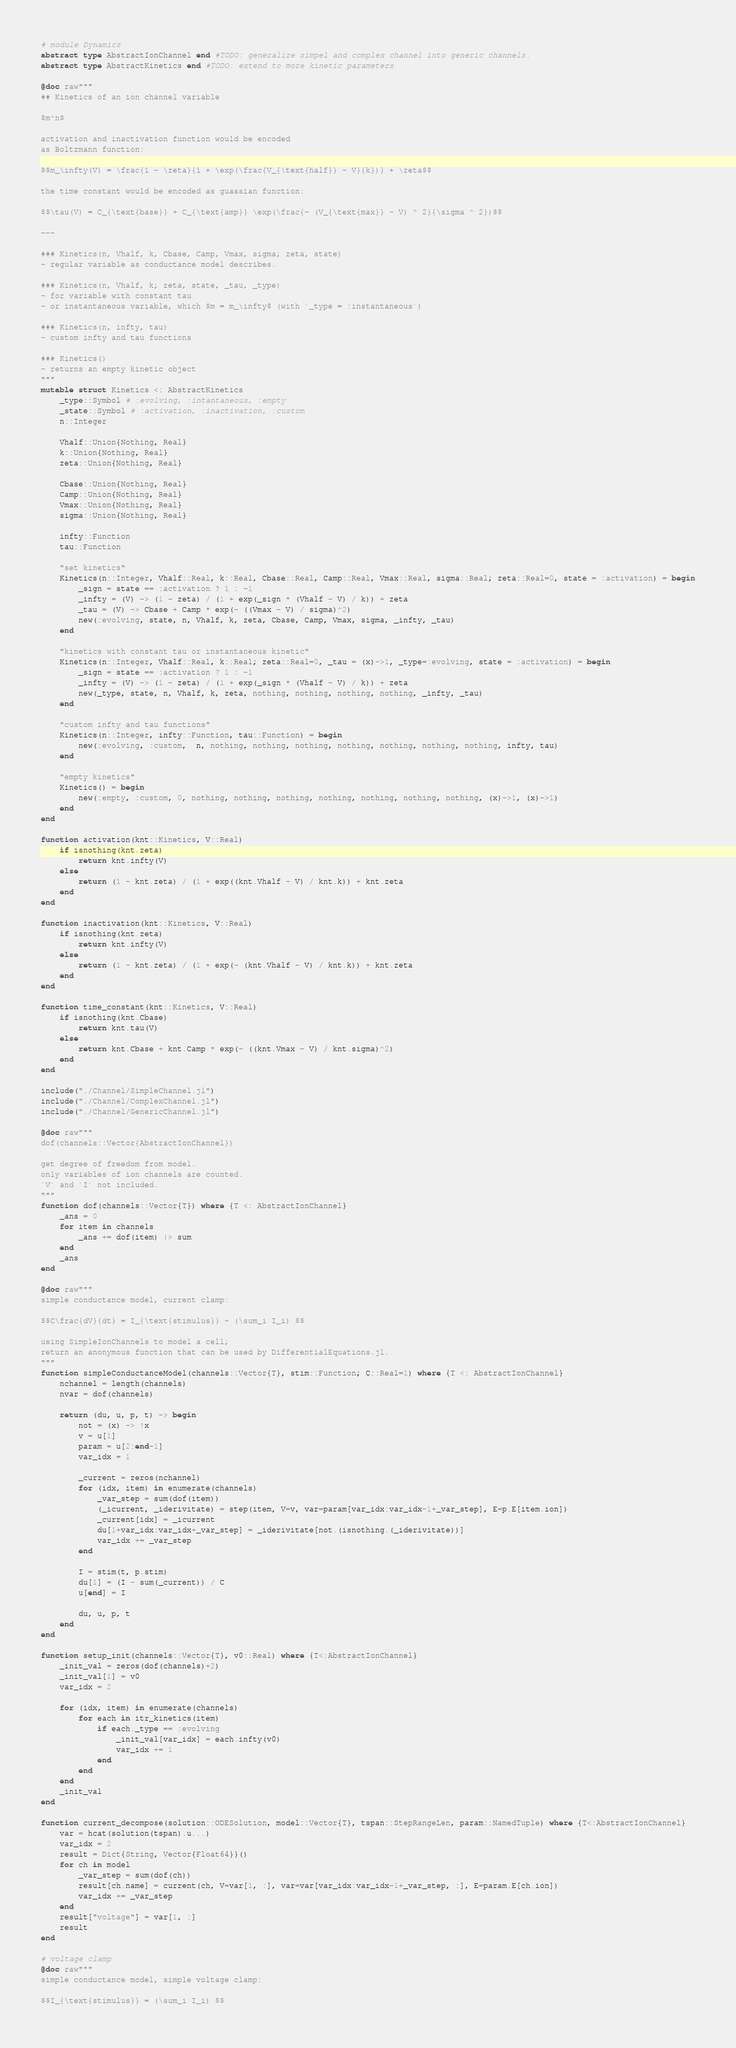Convert code to text. <code><loc_0><loc_0><loc_500><loc_500><_Julia_># module Dynamics
abstract type AbstractIonChannel end #TODO: generalize simpel and complex channel into generic channels.
abstract type AbstractKinetics end #TODO: extend to more kinetic parameters

@doc raw"""
## Kinetics of an ion channel variable

$m^n$

activation and inactivation function would be encoded
as Boltzmann function:

$$m_\infty(V) = \frac{1 - \zeta}{1 + \exp(\frac{V_{\text{half}} - V}{k})} + \zeta$$

the time constant would be encoded as guassian function:

$$\tau(V) = C_{\text{base}} + C_{\text{amp}} \exp(\frac{- (V_{\text{max}} - V) ^ 2}{\sigma ^ 2})$$

---

### Kinetics(n, Vhalf, k, Cbase, Camp, Vmax, sigma; zeta, state)
- regular variable as conductance model describes.

### Kinetics(n, Vhalf, k; zeta, state, _tau, _type)
- for variable with constant tau
- or instantaneous variable, which $m = m_\infty$ (with `_type = :instantaneous`)

### Kinetics(n, infty, tau)
- custom infty and tau functions

### Kinetics()
- returns an empty kinetic object
"""
mutable struct Kinetics <: AbstractKinetics
    _type::Symbol # :evolving, :intantaneous, :empty
    _state::Symbol # :activation, :inactivation, :custom
    n::Integer
    
    Vhalf::Union{Nothing, Real}
    k::Union{Nothing, Real}
    zeta::Union{Nothing, Real}

    Cbase::Union{Nothing, Real}
    Camp::Union{Nothing, Real}
    Vmax::Union{Nothing, Real}
    sigma::Union{Nothing, Real}

    infty::Function
    tau::Function

    "set kinetics"
    Kinetics(n::Integer, Vhalf::Real, k::Real, Cbase::Real, Camp::Real, Vmax::Real, sigma::Real; zeta::Real=0, state = :activation) = begin
        _sign = state == :activation ? 1 : -1
        _infty = (V) -> (1 - zeta) / (1 + exp(_sign * (Vhalf - V) / k)) + zeta
        _tau = (V) -> Cbase + Camp * exp(- ((Vmax - V) / sigma)^2)
        new(:evolving, state, n, Vhalf, k, zeta, Cbase, Camp, Vmax, sigma, _infty, _tau)
    end

    "kinetics with constant tau or instantaneous kinetic"
    Kinetics(n::Integer, Vhalf::Real, k::Real; zeta::Real=0, _tau = (x)->1, _type=:evolving, state = :activation) = begin
        _sign = state == :activation ? 1 : -1
        _infty = (V) -> (1 - zeta) / (1 + exp(_sign * (Vhalf - V) / k)) + zeta
        new(_type, state, n, Vhalf, k, zeta, nothing, nothing, nothing, nothing, _infty, _tau)
    end

    "custom infty and tau functions"
    Kinetics(n::Integer, infty::Function, tau::Function) = begin
        new(:evolving, :custom,  n, nothing, nothing, nothing, nothing, nothing, nothing, nothing, infty, tau)
    end

    "empty kinetics"
    Kinetics() = begin
        new(:empty, :custom, 0, nothing, nothing, nothing, nothing, nothing, nothing, nothing, (x)->1, (x)->1)
    end
end

function activation(knt::Kinetics, V::Real)
    if isnothing(knt.zeta)
        return knt.infty(V)
    else
        return (1 - knt.zeta) / (1 + exp((knt.Vhalf - V) / knt.k)) + knt.zeta
    end
end

function inactivation(knt::Kinetics, V::Real)
    if isnothing(knt.zeta)
        return knt.infty(V)
    else
        return (1 - knt.zeta) / (1 + exp(- (knt.Vhalf - V) / knt.k)) + knt.zeta
    end
end

function time_constant(knt::Kinetics, V::Real)
    if isnothing(knt.Cbase)
        return knt.tau(V)
    else
        return knt.Cbase + knt.Camp * exp(- ((knt.Vmax - V) / knt.sigma)^2)
    end
end

include("./Channel/SimpleChannel.jl")
include("./Channel/ComplexChannel.jl")
include("./Channel/GenericChannel.jl")

@doc raw"""
dof(channels::Vector{AbstractIonChannel})

get degree of freedom from model.
only variables of ion channels are counted.
`V` and `I` not included.
"""
function dof(channels::Vector{T}) where {T <: AbstractIonChannel}
    _ans = 0
    for item in channels
        _ans += dof(item) |> sum
    end
    _ans
end

@doc raw"""
simple conductance model, current clamp:

$$C\frac{dV}{dt} = I_{\text{stimulus}} - (\sum_i I_i) $$

using SimpleIonChannels to model a cell;
return an anonymous function that can be used by DifferentialEquations.jl.
"""
function simpleConductanceModel(channels::Vector{T}, stim::Function; C::Real=1) where {T <: AbstractIonChannel}
    nchannel = length(channels)
    nvar = dof(channels)
    
    return (du, u, p, t) -> begin
        not = (x) -> !x
        v = u[1]
        param = u[2:end-1]
        var_idx = 1
        
        _current = zeros(nchannel)
        for (idx, item) in enumerate(channels)
            _var_step = sum(dof(item))
            (_icurrent, _iderivitate) = step(item, V=v, var=param[var_idx:var_idx-1+_var_step], E=p.E[item.ion])
            _current[idx] = _icurrent
            du[1+var_idx:var_idx+_var_step] = _iderivitate[not.(isnothing.(_iderivitate))]
            var_idx += _var_step
        end
        
        I = stim(t, p.stim)
        du[1] = (I - sum(_current)) / C
        u[end] = I
        
        du, u, p, t
    end
end

function setup_init(channels::Vector{T}, v0::Real) where {T<:AbstractIonChannel}
    _init_val = zeros(dof(channels)+2)
    _init_val[1] = v0
    var_idx = 2
    
    for (idx, item) in enumerate(channels)
        for each in itr_kinetics(item)
            if each._type == :evolving
                _init_val[var_idx] = each.infty(v0)
                var_idx += 1
            end
        end
    end
    _init_val
end

function current_decompose(solution::ODESolution, model::Vector{T}, tspan::StepRangeLen, param::NamedTuple) where {T<:AbstractIonChannel}
    var = hcat(solution(tspan).u...)
    var_idx = 2
    result = Dict{String, Vector{Float64}}()
    for ch in model
        _var_step = sum(dof(ch))
        result[ch.name] = current(ch, V=var[1, :], var=var[var_idx:var_idx-1+_var_step, :], E=param.E[ch.ion])
        var_idx += _var_step
    end
    result["voltage"] = var[1, :]
    result
end

# voltage clamp
@doc raw"""
simple conductance model, simple voltage clamp:

$$I_{\text{stimulus}} = (\sum_i I_i) $$
</code> 